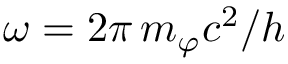<formula> <loc_0><loc_0><loc_500><loc_500>\omega = 2 \pi \, m _ { \varphi } c ^ { 2 } / h</formula> 